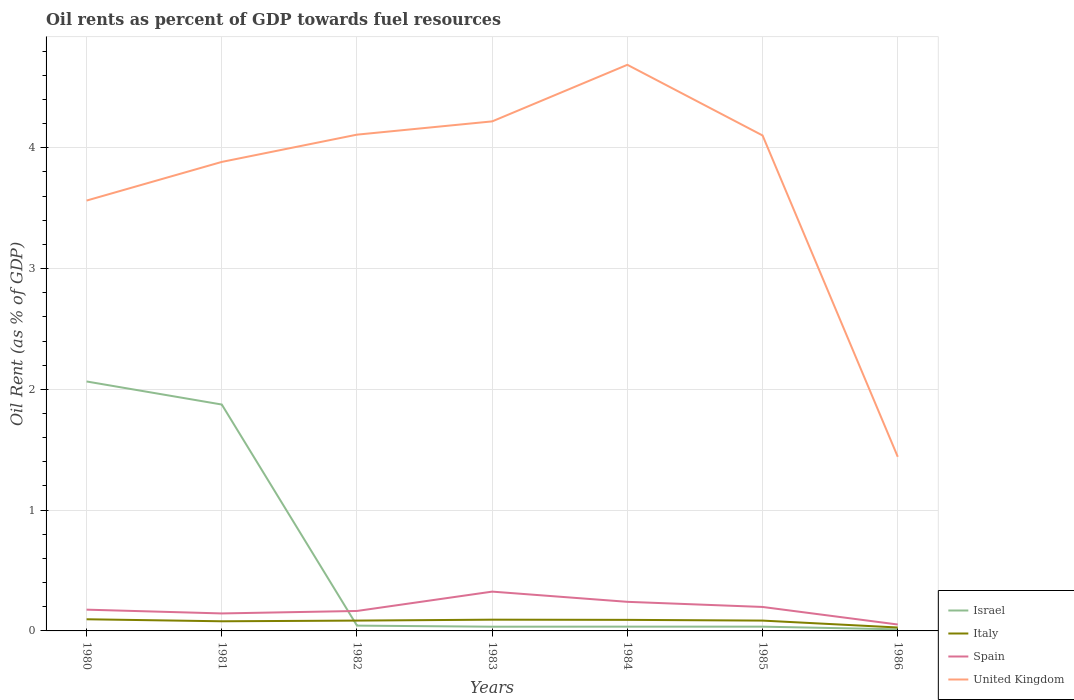How many different coloured lines are there?
Your answer should be very brief. 4. Across all years, what is the maximum oil rent in Israel?
Offer a terse response. 0.01. What is the total oil rent in Israel in the graph?
Give a very brief answer. 0.01. What is the difference between the highest and the second highest oil rent in United Kingdom?
Your response must be concise. 3.25. What is the difference between the highest and the lowest oil rent in United Kingdom?
Keep it short and to the point. 5. Is the oil rent in Spain strictly greater than the oil rent in Israel over the years?
Ensure brevity in your answer.  No. How many years are there in the graph?
Offer a very short reply. 7. What is the difference between two consecutive major ticks on the Y-axis?
Ensure brevity in your answer.  1. Where does the legend appear in the graph?
Offer a very short reply. Bottom right. What is the title of the graph?
Your answer should be very brief. Oil rents as percent of GDP towards fuel resources. Does "Channel Islands" appear as one of the legend labels in the graph?
Provide a short and direct response. No. What is the label or title of the Y-axis?
Your answer should be very brief. Oil Rent (as % of GDP). What is the Oil Rent (as % of GDP) of Israel in 1980?
Keep it short and to the point. 2.07. What is the Oil Rent (as % of GDP) of Italy in 1980?
Your answer should be compact. 0.1. What is the Oil Rent (as % of GDP) in Spain in 1980?
Your answer should be compact. 0.18. What is the Oil Rent (as % of GDP) of United Kingdom in 1980?
Offer a terse response. 3.56. What is the Oil Rent (as % of GDP) in Israel in 1981?
Ensure brevity in your answer.  1.87. What is the Oil Rent (as % of GDP) of Italy in 1981?
Keep it short and to the point. 0.08. What is the Oil Rent (as % of GDP) of Spain in 1981?
Give a very brief answer. 0.14. What is the Oil Rent (as % of GDP) in United Kingdom in 1981?
Give a very brief answer. 3.88. What is the Oil Rent (as % of GDP) of Israel in 1982?
Provide a succinct answer. 0.04. What is the Oil Rent (as % of GDP) of Italy in 1982?
Your response must be concise. 0.09. What is the Oil Rent (as % of GDP) in Spain in 1982?
Ensure brevity in your answer.  0.17. What is the Oil Rent (as % of GDP) of United Kingdom in 1982?
Your answer should be very brief. 4.11. What is the Oil Rent (as % of GDP) in Israel in 1983?
Your answer should be compact. 0.03. What is the Oil Rent (as % of GDP) of Italy in 1983?
Keep it short and to the point. 0.09. What is the Oil Rent (as % of GDP) in Spain in 1983?
Keep it short and to the point. 0.33. What is the Oil Rent (as % of GDP) of United Kingdom in 1983?
Give a very brief answer. 4.22. What is the Oil Rent (as % of GDP) of Israel in 1984?
Ensure brevity in your answer.  0.04. What is the Oil Rent (as % of GDP) in Italy in 1984?
Provide a succinct answer. 0.09. What is the Oil Rent (as % of GDP) in Spain in 1984?
Offer a very short reply. 0.24. What is the Oil Rent (as % of GDP) of United Kingdom in 1984?
Ensure brevity in your answer.  4.69. What is the Oil Rent (as % of GDP) in Israel in 1985?
Make the answer very short. 0.04. What is the Oil Rent (as % of GDP) of Italy in 1985?
Keep it short and to the point. 0.09. What is the Oil Rent (as % of GDP) of Spain in 1985?
Your response must be concise. 0.2. What is the Oil Rent (as % of GDP) of United Kingdom in 1985?
Offer a terse response. 4.1. What is the Oil Rent (as % of GDP) in Israel in 1986?
Give a very brief answer. 0.01. What is the Oil Rent (as % of GDP) of Italy in 1986?
Offer a very short reply. 0.03. What is the Oil Rent (as % of GDP) in Spain in 1986?
Your response must be concise. 0.05. What is the Oil Rent (as % of GDP) of United Kingdom in 1986?
Offer a terse response. 1.44. Across all years, what is the maximum Oil Rent (as % of GDP) of Israel?
Provide a succinct answer. 2.07. Across all years, what is the maximum Oil Rent (as % of GDP) in Italy?
Give a very brief answer. 0.1. Across all years, what is the maximum Oil Rent (as % of GDP) in Spain?
Provide a short and direct response. 0.33. Across all years, what is the maximum Oil Rent (as % of GDP) in United Kingdom?
Give a very brief answer. 4.69. Across all years, what is the minimum Oil Rent (as % of GDP) in Israel?
Your answer should be very brief. 0.01. Across all years, what is the minimum Oil Rent (as % of GDP) in Italy?
Make the answer very short. 0.03. Across all years, what is the minimum Oil Rent (as % of GDP) of Spain?
Keep it short and to the point. 0.05. Across all years, what is the minimum Oil Rent (as % of GDP) of United Kingdom?
Keep it short and to the point. 1.44. What is the total Oil Rent (as % of GDP) in Israel in the graph?
Provide a succinct answer. 4.1. What is the total Oil Rent (as % of GDP) of Italy in the graph?
Offer a terse response. 0.56. What is the total Oil Rent (as % of GDP) of Spain in the graph?
Ensure brevity in your answer.  1.3. What is the total Oil Rent (as % of GDP) in United Kingdom in the graph?
Your response must be concise. 26. What is the difference between the Oil Rent (as % of GDP) of Israel in 1980 and that in 1981?
Your response must be concise. 0.19. What is the difference between the Oil Rent (as % of GDP) in Italy in 1980 and that in 1981?
Offer a very short reply. 0.02. What is the difference between the Oil Rent (as % of GDP) of Spain in 1980 and that in 1981?
Ensure brevity in your answer.  0.03. What is the difference between the Oil Rent (as % of GDP) in United Kingdom in 1980 and that in 1981?
Offer a very short reply. -0.32. What is the difference between the Oil Rent (as % of GDP) of Israel in 1980 and that in 1982?
Keep it short and to the point. 2.02. What is the difference between the Oil Rent (as % of GDP) in Italy in 1980 and that in 1982?
Keep it short and to the point. 0.01. What is the difference between the Oil Rent (as % of GDP) in Spain in 1980 and that in 1982?
Offer a terse response. 0.01. What is the difference between the Oil Rent (as % of GDP) of United Kingdom in 1980 and that in 1982?
Your answer should be very brief. -0.55. What is the difference between the Oil Rent (as % of GDP) of Israel in 1980 and that in 1983?
Your answer should be very brief. 2.03. What is the difference between the Oil Rent (as % of GDP) in Italy in 1980 and that in 1983?
Keep it short and to the point. 0. What is the difference between the Oil Rent (as % of GDP) of Spain in 1980 and that in 1983?
Offer a very short reply. -0.15. What is the difference between the Oil Rent (as % of GDP) in United Kingdom in 1980 and that in 1983?
Make the answer very short. -0.66. What is the difference between the Oil Rent (as % of GDP) of Israel in 1980 and that in 1984?
Your answer should be compact. 2.03. What is the difference between the Oil Rent (as % of GDP) of Italy in 1980 and that in 1984?
Give a very brief answer. 0. What is the difference between the Oil Rent (as % of GDP) of Spain in 1980 and that in 1984?
Offer a terse response. -0.06. What is the difference between the Oil Rent (as % of GDP) in United Kingdom in 1980 and that in 1984?
Offer a very short reply. -1.12. What is the difference between the Oil Rent (as % of GDP) of Israel in 1980 and that in 1985?
Offer a terse response. 2.03. What is the difference between the Oil Rent (as % of GDP) in Italy in 1980 and that in 1985?
Your answer should be very brief. 0.01. What is the difference between the Oil Rent (as % of GDP) in Spain in 1980 and that in 1985?
Give a very brief answer. -0.02. What is the difference between the Oil Rent (as % of GDP) of United Kingdom in 1980 and that in 1985?
Your response must be concise. -0.54. What is the difference between the Oil Rent (as % of GDP) of Israel in 1980 and that in 1986?
Your answer should be compact. 2.05. What is the difference between the Oil Rent (as % of GDP) in Italy in 1980 and that in 1986?
Give a very brief answer. 0.07. What is the difference between the Oil Rent (as % of GDP) of Spain in 1980 and that in 1986?
Give a very brief answer. 0.12. What is the difference between the Oil Rent (as % of GDP) in United Kingdom in 1980 and that in 1986?
Give a very brief answer. 2.12. What is the difference between the Oil Rent (as % of GDP) in Israel in 1981 and that in 1982?
Offer a very short reply. 1.83. What is the difference between the Oil Rent (as % of GDP) of Italy in 1981 and that in 1982?
Offer a very short reply. -0.01. What is the difference between the Oil Rent (as % of GDP) of Spain in 1981 and that in 1982?
Make the answer very short. -0.02. What is the difference between the Oil Rent (as % of GDP) in United Kingdom in 1981 and that in 1982?
Your response must be concise. -0.23. What is the difference between the Oil Rent (as % of GDP) in Israel in 1981 and that in 1983?
Your answer should be compact. 1.84. What is the difference between the Oil Rent (as % of GDP) of Italy in 1981 and that in 1983?
Offer a terse response. -0.01. What is the difference between the Oil Rent (as % of GDP) in Spain in 1981 and that in 1983?
Offer a terse response. -0.18. What is the difference between the Oil Rent (as % of GDP) of United Kingdom in 1981 and that in 1983?
Your answer should be compact. -0.34. What is the difference between the Oil Rent (as % of GDP) in Israel in 1981 and that in 1984?
Your answer should be very brief. 1.84. What is the difference between the Oil Rent (as % of GDP) in Italy in 1981 and that in 1984?
Ensure brevity in your answer.  -0.01. What is the difference between the Oil Rent (as % of GDP) of Spain in 1981 and that in 1984?
Keep it short and to the point. -0.1. What is the difference between the Oil Rent (as % of GDP) of United Kingdom in 1981 and that in 1984?
Your answer should be very brief. -0.8. What is the difference between the Oil Rent (as % of GDP) of Israel in 1981 and that in 1985?
Provide a succinct answer. 1.84. What is the difference between the Oil Rent (as % of GDP) in Italy in 1981 and that in 1985?
Provide a succinct answer. -0.01. What is the difference between the Oil Rent (as % of GDP) of Spain in 1981 and that in 1985?
Ensure brevity in your answer.  -0.05. What is the difference between the Oil Rent (as % of GDP) of United Kingdom in 1981 and that in 1985?
Make the answer very short. -0.22. What is the difference between the Oil Rent (as % of GDP) of Israel in 1981 and that in 1986?
Your answer should be very brief. 1.86. What is the difference between the Oil Rent (as % of GDP) in Italy in 1981 and that in 1986?
Your response must be concise. 0.05. What is the difference between the Oil Rent (as % of GDP) in Spain in 1981 and that in 1986?
Your answer should be compact. 0.09. What is the difference between the Oil Rent (as % of GDP) in United Kingdom in 1981 and that in 1986?
Provide a short and direct response. 2.44. What is the difference between the Oil Rent (as % of GDP) of Israel in 1982 and that in 1983?
Provide a short and direct response. 0.01. What is the difference between the Oil Rent (as % of GDP) of Italy in 1982 and that in 1983?
Your answer should be compact. -0.01. What is the difference between the Oil Rent (as % of GDP) of Spain in 1982 and that in 1983?
Provide a short and direct response. -0.16. What is the difference between the Oil Rent (as % of GDP) of United Kingdom in 1982 and that in 1983?
Make the answer very short. -0.11. What is the difference between the Oil Rent (as % of GDP) of Israel in 1982 and that in 1984?
Give a very brief answer. 0.01. What is the difference between the Oil Rent (as % of GDP) in Italy in 1982 and that in 1984?
Give a very brief answer. -0.01. What is the difference between the Oil Rent (as % of GDP) in Spain in 1982 and that in 1984?
Give a very brief answer. -0.08. What is the difference between the Oil Rent (as % of GDP) of United Kingdom in 1982 and that in 1984?
Your response must be concise. -0.58. What is the difference between the Oil Rent (as % of GDP) of Israel in 1982 and that in 1985?
Offer a very short reply. 0.01. What is the difference between the Oil Rent (as % of GDP) of Italy in 1982 and that in 1985?
Provide a short and direct response. 0. What is the difference between the Oil Rent (as % of GDP) of Spain in 1982 and that in 1985?
Provide a short and direct response. -0.03. What is the difference between the Oil Rent (as % of GDP) of United Kingdom in 1982 and that in 1985?
Your response must be concise. 0.01. What is the difference between the Oil Rent (as % of GDP) in Israel in 1982 and that in 1986?
Offer a very short reply. 0.03. What is the difference between the Oil Rent (as % of GDP) of Italy in 1982 and that in 1986?
Your response must be concise. 0.06. What is the difference between the Oil Rent (as % of GDP) of Spain in 1982 and that in 1986?
Ensure brevity in your answer.  0.11. What is the difference between the Oil Rent (as % of GDP) in United Kingdom in 1982 and that in 1986?
Give a very brief answer. 2.67. What is the difference between the Oil Rent (as % of GDP) in Israel in 1983 and that in 1984?
Your answer should be very brief. -0. What is the difference between the Oil Rent (as % of GDP) of Italy in 1983 and that in 1984?
Provide a short and direct response. 0. What is the difference between the Oil Rent (as % of GDP) in Spain in 1983 and that in 1984?
Make the answer very short. 0.08. What is the difference between the Oil Rent (as % of GDP) in United Kingdom in 1983 and that in 1984?
Offer a very short reply. -0.47. What is the difference between the Oil Rent (as % of GDP) of Israel in 1983 and that in 1985?
Keep it short and to the point. -0. What is the difference between the Oil Rent (as % of GDP) of Italy in 1983 and that in 1985?
Keep it short and to the point. 0.01. What is the difference between the Oil Rent (as % of GDP) of Spain in 1983 and that in 1985?
Keep it short and to the point. 0.13. What is the difference between the Oil Rent (as % of GDP) in United Kingdom in 1983 and that in 1985?
Provide a succinct answer. 0.12. What is the difference between the Oil Rent (as % of GDP) of Israel in 1983 and that in 1986?
Keep it short and to the point. 0.02. What is the difference between the Oil Rent (as % of GDP) in Italy in 1983 and that in 1986?
Give a very brief answer. 0.06. What is the difference between the Oil Rent (as % of GDP) of Spain in 1983 and that in 1986?
Provide a succinct answer. 0.27. What is the difference between the Oil Rent (as % of GDP) in United Kingdom in 1983 and that in 1986?
Provide a succinct answer. 2.78. What is the difference between the Oil Rent (as % of GDP) of Italy in 1984 and that in 1985?
Ensure brevity in your answer.  0.01. What is the difference between the Oil Rent (as % of GDP) of Spain in 1984 and that in 1985?
Make the answer very short. 0.04. What is the difference between the Oil Rent (as % of GDP) in United Kingdom in 1984 and that in 1985?
Provide a short and direct response. 0.58. What is the difference between the Oil Rent (as % of GDP) in Israel in 1984 and that in 1986?
Provide a short and direct response. 0.02. What is the difference between the Oil Rent (as % of GDP) of Italy in 1984 and that in 1986?
Make the answer very short. 0.06. What is the difference between the Oil Rent (as % of GDP) of Spain in 1984 and that in 1986?
Provide a short and direct response. 0.19. What is the difference between the Oil Rent (as % of GDP) of United Kingdom in 1984 and that in 1986?
Offer a very short reply. 3.25. What is the difference between the Oil Rent (as % of GDP) in Israel in 1985 and that in 1986?
Your answer should be compact. 0.02. What is the difference between the Oil Rent (as % of GDP) of Italy in 1985 and that in 1986?
Make the answer very short. 0.06. What is the difference between the Oil Rent (as % of GDP) of Spain in 1985 and that in 1986?
Provide a succinct answer. 0.15. What is the difference between the Oil Rent (as % of GDP) of United Kingdom in 1985 and that in 1986?
Your response must be concise. 2.66. What is the difference between the Oil Rent (as % of GDP) of Israel in 1980 and the Oil Rent (as % of GDP) of Italy in 1981?
Your answer should be compact. 1.99. What is the difference between the Oil Rent (as % of GDP) in Israel in 1980 and the Oil Rent (as % of GDP) in Spain in 1981?
Provide a succinct answer. 1.92. What is the difference between the Oil Rent (as % of GDP) in Israel in 1980 and the Oil Rent (as % of GDP) in United Kingdom in 1981?
Provide a succinct answer. -1.82. What is the difference between the Oil Rent (as % of GDP) of Italy in 1980 and the Oil Rent (as % of GDP) of Spain in 1981?
Your response must be concise. -0.05. What is the difference between the Oil Rent (as % of GDP) of Italy in 1980 and the Oil Rent (as % of GDP) of United Kingdom in 1981?
Your answer should be compact. -3.79. What is the difference between the Oil Rent (as % of GDP) of Spain in 1980 and the Oil Rent (as % of GDP) of United Kingdom in 1981?
Your answer should be very brief. -3.71. What is the difference between the Oil Rent (as % of GDP) of Israel in 1980 and the Oil Rent (as % of GDP) of Italy in 1982?
Ensure brevity in your answer.  1.98. What is the difference between the Oil Rent (as % of GDP) in Israel in 1980 and the Oil Rent (as % of GDP) in Spain in 1982?
Your answer should be compact. 1.9. What is the difference between the Oil Rent (as % of GDP) in Israel in 1980 and the Oil Rent (as % of GDP) in United Kingdom in 1982?
Your answer should be very brief. -2.04. What is the difference between the Oil Rent (as % of GDP) in Italy in 1980 and the Oil Rent (as % of GDP) in Spain in 1982?
Give a very brief answer. -0.07. What is the difference between the Oil Rent (as % of GDP) in Italy in 1980 and the Oil Rent (as % of GDP) in United Kingdom in 1982?
Keep it short and to the point. -4.01. What is the difference between the Oil Rent (as % of GDP) in Spain in 1980 and the Oil Rent (as % of GDP) in United Kingdom in 1982?
Offer a very short reply. -3.93. What is the difference between the Oil Rent (as % of GDP) in Israel in 1980 and the Oil Rent (as % of GDP) in Italy in 1983?
Give a very brief answer. 1.97. What is the difference between the Oil Rent (as % of GDP) in Israel in 1980 and the Oil Rent (as % of GDP) in Spain in 1983?
Your answer should be very brief. 1.74. What is the difference between the Oil Rent (as % of GDP) in Israel in 1980 and the Oil Rent (as % of GDP) in United Kingdom in 1983?
Keep it short and to the point. -2.15. What is the difference between the Oil Rent (as % of GDP) of Italy in 1980 and the Oil Rent (as % of GDP) of Spain in 1983?
Provide a short and direct response. -0.23. What is the difference between the Oil Rent (as % of GDP) in Italy in 1980 and the Oil Rent (as % of GDP) in United Kingdom in 1983?
Provide a short and direct response. -4.12. What is the difference between the Oil Rent (as % of GDP) of Spain in 1980 and the Oil Rent (as % of GDP) of United Kingdom in 1983?
Provide a short and direct response. -4.04. What is the difference between the Oil Rent (as % of GDP) in Israel in 1980 and the Oil Rent (as % of GDP) in Italy in 1984?
Offer a very short reply. 1.97. What is the difference between the Oil Rent (as % of GDP) of Israel in 1980 and the Oil Rent (as % of GDP) of Spain in 1984?
Offer a very short reply. 1.82. What is the difference between the Oil Rent (as % of GDP) of Israel in 1980 and the Oil Rent (as % of GDP) of United Kingdom in 1984?
Keep it short and to the point. -2.62. What is the difference between the Oil Rent (as % of GDP) of Italy in 1980 and the Oil Rent (as % of GDP) of Spain in 1984?
Keep it short and to the point. -0.14. What is the difference between the Oil Rent (as % of GDP) in Italy in 1980 and the Oil Rent (as % of GDP) in United Kingdom in 1984?
Make the answer very short. -4.59. What is the difference between the Oil Rent (as % of GDP) in Spain in 1980 and the Oil Rent (as % of GDP) in United Kingdom in 1984?
Your answer should be very brief. -4.51. What is the difference between the Oil Rent (as % of GDP) in Israel in 1980 and the Oil Rent (as % of GDP) in Italy in 1985?
Your response must be concise. 1.98. What is the difference between the Oil Rent (as % of GDP) of Israel in 1980 and the Oil Rent (as % of GDP) of Spain in 1985?
Your answer should be compact. 1.87. What is the difference between the Oil Rent (as % of GDP) in Israel in 1980 and the Oil Rent (as % of GDP) in United Kingdom in 1985?
Keep it short and to the point. -2.04. What is the difference between the Oil Rent (as % of GDP) of Italy in 1980 and the Oil Rent (as % of GDP) of Spain in 1985?
Ensure brevity in your answer.  -0.1. What is the difference between the Oil Rent (as % of GDP) in Italy in 1980 and the Oil Rent (as % of GDP) in United Kingdom in 1985?
Your answer should be compact. -4.01. What is the difference between the Oil Rent (as % of GDP) in Spain in 1980 and the Oil Rent (as % of GDP) in United Kingdom in 1985?
Provide a short and direct response. -3.93. What is the difference between the Oil Rent (as % of GDP) of Israel in 1980 and the Oil Rent (as % of GDP) of Italy in 1986?
Give a very brief answer. 2.04. What is the difference between the Oil Rent (as % of GDP) in Israel in 1980 and the Oil Rent (as % of GDP) in Spain in 1986?
Give a very brief answer. 2.01. What is the difference between the Oil Rent (as % of GDP) in Israel in 1980 and the Oil Rent (as % of GDP) in United Kingdom in 1986?
Keep it short and to the point. 0.62. What is the difference between the Oil Rent (as % of GDP) of Italy in 1980 and the Oil Rent (as % of GDP) of Spain in 1986?
Provide a succinct answer. 0.04. What is the difference between the Oil Rent (as % of GDP) in Italy in 1980 and the Oil Rent (as % of GDP) in United Kingdom in 1986?
Your answer should be compact. -1.34. What is the difference between the Oil Rent (as % of GDP) in Spain in 1980 and the Oil Rent (as % of GDP) in United Kingdom in 1986?
Your response must be concise. -1.27. What is the difference between the Oil Rent (as % of GDP) of Israel in 1981 and the Oil Rent (as % of GDP) of Italy in 1982?
Make the answer very short. 1.79. What is the difference between the Oil Rent (as % of GDP) in Israel in 1981 and the Oil Rent (as % of GDP) in Spain in 1982?
Keep it short and to the point. 1.71. What is the difference between the Oil Rent (as % of GDP) of Israel in 1981 and the Oil Rent (as % of GDP) of United Kingdom in 1982?
Your answer should be compact. -2.23. What is the difference between the Oil Rent (as % of GDP) in Italy in 1981 and the Oil Rent (as % of GDP) in Spain in 1982?
Your answer should be very brief. -0.09. What is the difference between the Oil Rent (as % of GDP) in Italy in 1981 and the Oil Rent (as % of GDP) in United Kingdom in 1982?
Give a very brief answer. -4.03. What is the difference between the Oil Rent (as % of GDP) of Spain in 1981 and the Oil Rent (as % of GDP) of United Kingdom in 1982?
Provide a succinct answer. -3.96. What is the difference between the Oil Rent (as % of GDP) of Israel in 1981 and the Oil Rent (as % of GDP) of Italy in 1983?
Your answer should be very brief. 1.78. What is the difference between the Oil Rent (as % of GDP) of Israel in 1981 and the Oil Rent (as % of GDP) of Spain in 1983?
Make the answer very short. 1.55. What is the difference between the Oil Rent (as % of GDP) in Israel in 1981 and the Oil Rent (as % of GDP) in United Kingdom in 1983?
Offer a terse response. -2.34. What is the difference between the Oil Rent (as % of GDP) of Italy in 1981 and the Oil Rent (as % of GDP) of Spain in 1983?
Make the answer very short. -0.25. What is the difference between the Oil Rent (as % of GDP) of Italy in 1981 and the Oil Rent (as % of GDP) of United Kingdom in 1983?
Make the answer very short. -4.14. What is the difference between the Oil Rent (as % of GDP) in Spain in 1981 and the Oil Rent (as % of GDP) in United Kingdom in 1983?
Your response must be concise. -4.07. What is the difference between the Oil Rent (as % of GDP) in Israel in 1981 and the Oil Rent (as % of GDP) in Italy in 1984?
Give a very brief answer. 1.78. What is the difference between the Oil Rent (as % of GDP) in Israel in 1981 and the Oil Rent (as % of GDP) in Spain in 1984?
Offer a terse response. 1.63. What is the difference between the Oil Rent (as % of GDP) of Israel in 1981 and the Oil Rent (as % of GDP) of United Kingdom in 1984?
Provide a short and direct response. -2.81. What is the difference between the Oil Rent (as % of GDP) of Italy in 1981 and the Oil Rent (as % of GDP) of Spain in 1984?
Your answer should be very brief. -0.16. What is the difference between the Oil Rent (as % of GDP) in Italy in 1981 and the Oil Rent (as % of GDP) in United Kingdom in 1984?
Your answer should be very brief. -4.61. What is the difference between the Oil Rent (as % of GDP) in Spain in 1981 and the Oil Rent (as % of GDP) in United Kingdom in 1984?
Offer a terse response. -4.54. What is the difference between the Oil Rent (as % of GDP) in Israel in 1981 and the Oil Rent (as % of GDP) in Italy in 1985?
Keep it short and to the point. 1.79. What is the difference between the Oil Rent (as % of GDP) in Israel in 1981 and the Oil Rent (as % of GDP) in Spain in 1985?
Provide a short and direct response. 1.68. What is the difference between the Oil Rent (as % of GDP) of Israel in 1981 and the Oil Rent (as % of GDP) of United Kingdom in 1985?
Give a very brief answer. -2.23. What is the difference between the Oil Rent (as % of GDP) of Italy in 1981 and the Oil Rent (as % of GDP) of Spain in 1985?
Offer a terse response. -0.12. What is the difference between the Oil Rent (as % of GDP) in Italy in 1981 and the Oil Rent (as % of GDP) in United Kingdom in 1985?
Keep it short and to the point. -4.02. What is the difference between the Oil Rent (as % of GDP) in Spain in 1981 and the Oil Rent (as % of GDP) in United Kingdom in 1985?
Make the answer very short. -3.96. What is the difference between the Oil Rent (as % of GDP) of Israel in 1981 and the Oil Rent (as % of GDP) of Italy in 1986?
Keep it short and to the point. 1.85. What is the difference between the Oil Rent (as % of GDP) in Israel in 1981 and the Oil Rent (as % of GDP) in Spain in 1986?
Provide a short and direct response. 1.82. What is the difference between the Oil Rent (as % of GDP) in Israel in 1981 and the Oil Rent (as % of GDP) in United Kingdom in 1986?
Your response must be concise. 0.43. What is the difference between the Oil Rent (as % of GDP) in Italy in 1981 and the Oil Rent (as % of GDP) in Spain in 1986?
Offer a very short reply. 0.03. What is the difference between the Oil Rent (as % of GDP) in Italy in 1981 and the Oil Rent (as % of GDP) in United Kingdom in 1986?
Your answer should be very brief. -1.36. What is the difference between the Oil Rent (as % of GDP) of Spain in 1981 and the Oil Rent (as % of GDP) of United Kingdom in 1986?
Your answer should be compact. -1.3. What is the difference between the Oil Rent (as % of GDP) in Israel in 1982 and the Oil Rent (as % of GDP) in Italy in 1983?
Give a very brief answer. -0.05. What is the difference between the Oil Rent (as % of GDP) in Israel in 1982 and the Oil Rent (as % of GDP) in Spain in 1983?
Provide a short and direct response. -0.28. What is the difference between the Oil Rent (as % of GDP) in Israel in 1982 and the Oil Rent (as % of GDP) in United Kingdom in 1983?
Give a very brief answer. -4.17. What is the difference between the Oil Rent (as % of GDP) in Italy in 1982 and the Oil Rent (as % of GDP) in Spain in 1983?
Give a very brief answer. -0.24. What is the difference between the Oil Rent (as % of GDP) of Italy in 1982 and the Oil Rent (as % of GDP) of United Kingdom in 1983?
Ensure brevity in your answer.  -4.13. What is the difference between the Oil Rent (as % of GDP) of Spain in 1982 and the Oil Rent (as % of GDP) of United Kingdom in 1983?
Make the answer very short. -4.05. What is the difference between the Oil Rent (as % of GDP) of Israel in 1982 and the Oil Rent (as % of GDP) of Italy in 1984?
Make the answer very short. -0.05. What is the difference between the Oil Rent (as % of GDP) in Israel in 1982 and the Oil Rent (as % of GDP) in Spain in 1984?
Keep it short and to the point. -0.2. What is the difference between the Oil Rent (as % of GDP) of Israel in 1982 and the Oil Rent (as % of GDP) of United Kingdom in 1984?
Provide a short and direct response. -4.64. What is the difference between the Oil Rent (as % of GDP) in Italy in 1982 and the Oil Rent (as % of GDP) in Spain in 1984?
Provide a succinct answer. -0.16. What is the difference between the Oil Rent (as % of GDP) of Italy in 1982 and the Oil Rent (as % of GDP) of United Kingdom in 1984?
Provide a succinct answer. -4.6. What is the difference between the Oil Rent (as % of GDP) in Spain in 1982 and the Oil Rent (as % of GDP) in United Kingdom in 1984?
Give a very brief answer. -4.52. What is the difference between the Oil Rent (as % of GDP) in Israel in 1982 and the Oil Rent (as % of GDP) in Italy in 1985?
Offer a terse response. -0.04. What is the difference between the Oil Rent (as % of GDP) of Israel in 1982 and the Oil Rent (as % of GDP) of Spain in 1985?
Keep it short and to the point. -0.15. What is the difference between the Oil Rent (as % of GDP) in Israel in 1982 and the Oil Rent (as % of GDP) in United Kingdom in 1985?
Your answer should be very brief. -4.06. What is the difference between the Oil Rent (as % of GDP) of Italy in 1982 and the Oil Rent (as % of GDP) of Spain in 1985?
Your answer should be compact. -0.11. What is the difference between the Oil Rent (as % of GDP) of Italy in 1982 and the Oil Rent (as % of GDP) of United Kingdom in 1985?
Ensure brevity in your answer.  -4.02. What is the difference between the Oil Rent (as % of GDP) in Spain in 1982 and the Oil Rent (as % of GDP) in United Kingdom in 1985?
Keep it short and to the point. -3.94. What is the difference between the Oil Rent (as % of GDP) in Israel in 1982 and the Oil Rent (as % of GDP) in Italy in 1986?
Give a very brief answer. 0.02. What is the difference between the Oil Rent (as % of GDP) in Israel in 1982 and the Oil Rent (as % of GDP) in Spain in 1986?
Provide a succinct answer. -0.01. What is the difference between the Oil Rent (as % of GDP) of Israel in 1982 and the Oil Rent (as % of GDP) of United Kingdom in 1986?
Keep it short and to the point. -1.4. What is the difference between the Oil Rent (as % of GDP) of Italy in 1982 and the Oil Rent (as % of GDP) of Spain in 1986?
Give a very brief answer. 0.03. What is the difference between the Oil Rent (as % of GDP) of Italy in 1982 and the Oil Rent (as % of GDP) of United Kingdom in 1986?
Provide a short and direct response. -1.36. What is the difference between the Oil Rent (as % of GDP) in Spain in 1982 and the Oil Rent (as % of GDP) in United Kingdom in 1986?
Offer a very short reply. -1.28. What is the difference between the Oil Rent (as % of GDP) of Israel in 1983 and the Oil Rent (as % of GDP) of Italy in 1984?
Ensure brevity in your answer.  -0.06. What is the difference between the Oil Rent (as % of GDP) in Israel in 1983 and the Oil Rent (as % of GDP) in Spain in 1984?
Ensure brevity in your answer.  -0.21. What is the difference between the Oil Rent (as % of GDP) in Israel in 1983 and the Oil Rent (as % of GDP) in United Kingdom in 1984?
Offer a terse response. -4.65. What is the difference between the Oil Rent (as % of GDP) in Italy in 1983 and the Oil Rent (as % of GDP) in Spain in 1984?
Give a very brief answer. -0.15. What is the difference between the Oil Rent (as % of GDP) of Italy in 1983 and the Oil Rent (as % of GDP) of United Kingdom in 1984?
Your answer should be compact. -4.59. What is the difference between the Oil Rent (as % of GDP) of Spain in 1983 and the Oil Rent (as % of GDP) of United Kingdom in 1984?
Provide a short and direct response. -4.36. What is the difference between the Oil Rent (as % of GDP) of Israel in 1983 and the Oil Rent (as % of GDP) of Italy in 1985?
Provide a succinct answer. -0.05. What is the difference between the Oil Rent (as % of GDP) in Israel in 1983 and the Oil Rent (as % of GDP) in Spain in 1985?
Make the answer very short. -0.16. What is the difference between the Oil Rent (as % of GDP) of Israel in 1983 and the Oil Rent (as % of GDP) of United Kingdom in 1985?
Ensure brevity in your answer.  -4.07. What is the difference between the Oil Rent (as % of GDP) of Italy in 1983 and the Oil Rent (as % of GDP) of Spain in 1985?
Your answer should be compact. -0.11. What is the difference between the Oil Rent (as % of GDP) in Italy in 1983 and the Oil Rent (as % of GDP) in United Kingdom in 1985?
Provide a short and direct response. -4.01. What is the difference between the Oil Rent (as % of GDP) in Spain in 1983 and the Oil Rent (as % of GDP) in United Kingdom in 1985?
Give a very brief answer. -3.78. What is the difference between the Oil Rent (as % of GDP) of Israel in 1983 and the Oil Rent (as % of GDP) of Italy in 1986?
Make the answer very short. 0.01. What is the difference between the Oil Rent (as % of GDP) in Israel in 1983 and the Oil Rent (as % of GDP) in Spain in 1986?
Your response must be concise. -0.02. What is the difference between the Oil Rent (as % of GDP) in Israel in 1983 and the Oil Rent (as % of GDP) in United Kingdom in 1986?
Your answer should be compact. -1.41. What is the difference between the Oil Rent (as % of GDP) in Italy in 1983 and the Oil Rent (as % of GDP) in Spain in 1986?
Your answer should be very brief. 0.04. What is the difference between the Oil Rent (as % of GDP) of Italy in 1983 and the Oil Rent (as % of GDP) of United Kingdom in 1986?
Ensure brevity in your answer.  -1.35. What is the difference between the Oil Rent (as % of GDP) in Spain in 1983 and the Oil Rent (as % of GDP) in United Kingdom in 1986?
Make the answer very short. -1.12. What is the difference between the Oil Rent (as % of GDP) of Israel in 1984 and the Oil Rent (as % of GDP) of Italy in 1985?
Give a very brief answer. -0.05. What is the difference between the Oil Rent (as % of GDP) of Israel in 1984 and the Oil Rent (as % of GDP) of Spain in 1985?
Your response must be concise. -0.16. What is the difference between the Oil Rent (as % of GDP) of Israel in 1984 and the Oil Rent (as % of GDP) of United Kingdom in 1985?
Provide a short and direct response. -4.07. What is the difference between the Oil Rent (as % of GDP) of Italy in 1984 and the Oil Rent (as % of GDP) of Spain in 1985?
Your answer should be compact. -0.11. What is the difference between the Oil Rent (as % of GDP) of Italy in 1984 and the Oil Rent (as % of GDP) of United Kingdom in 1985?
Your response must be concise. -4.01. What is the difference between the Oil Rent (as % of GDP) in Spain in 1984 and the Oil Rent (as % of GDP) in United Kingdom in 1985?
Offer a very short reply. -3.86. What is the difference between the Oil Rent (as % of GDP) of Israel in 1984 and the Oil Rent (as % of GDP) of Italy in 1986?
Your answer should be very brief. 0.01. What is the difference between the Oil Rent (as % of GDP) of Israel in 1984 and the Oil Rent (as % of GDP) of Spain in 1986?
Provide a short and direct response. -0.02. What is the difference between the Oil Rent (as % of GDP) of Israel in 1984 and the Oil Rent (as % of GDP) of United Kingdom in 1986?
Your answer should be compact. -1.41. What is the difference between the Oil Rent (as % of GDP) in Italy in 1984 and the Oil Rent (as % of GDP) in Spain in 1986?
Your answer should be very brief. 0.04. What is the difference between the Oil Rent (as % of GDP) of Italy in 1984 and the Oil Rent (as % of GDP) of United Kingdom in 1986?
Ensure brevity in your answer.  -1.35. What is the difference between the Oil Rent (as % of GDP) in Spain in 1984 and the Oil Rent (as % of GDP) in United Kingdom in 1986?
Ensure brevity in your answer.  -1.2. What is the difference between the Oil Rent (as % of GDP) in Israel in 1985 and the Oil Rent (as % of GDP) in Italy in 1986?
Offer a very short reply. 0.01. What is the difference between the Oil Rent (as % of GDP) in Israel in 1985 and the Oil Rent (as % of GDP) in Spain in 1986?
Ensure brevity in your answer.  -0.02. What is the difference between the Oil Rent (as % of GDP) in Israel in 1985 and the Oil Rent (as % of GDP) in United Kingdom in 1986?
Offer a very short reply. -1.41. What is the difference between the Oil Rent (as % of GDP) in Italy in 1985 and the Oil Rent (as % of GDP) in Spain in 1986?
Ensure brevity in your answer.  0.03. What is the difference between the Oil Rent (as % of GDP) in Italy in 1985 and the Oil Rent (as % of GDP) in United Kingdom in 1986?
Provide a short and direct response. -1.36. What is the difference between the Oil Rent (as % of GDP) of Spain in 1985 and the Oil Rent (as % of GDP) of United Kingdom in 1986?
Offer a very short reply. -1.24. What is the average Oil Rent (as % of GDP) of Israel per year?
Keep it short and to the point. 0.59. What is the average Oil Rent (as % of GDP) in Spain per year?
Offer a very short reply. 0.19. What is the average Oil Rent (as % of GDP) in United Kingdom per year?
Ensure brevity in your answer.  3.71. In the year 1980, what is the difference between the Oil Rent (as % of GDP) of Israel and Oil Rent (as % of GDP) of Italy?
Your answer should be very brief. 1.97. In the year 1980, what is the difference between the Oil Rent (as % of GDP) in Israel and Oil Rent (as % of GDP) in Spain?
Your answer should be very brief. 1.89. In the year 1980, what is the difference between the Oil Rent (as % of GDP) of Israel and Oil Rent (as % of GDP) of United Kingdom?
Provide a short and direct response. -1.5. In the year 1980, what is the difference between the Oil Rent (as % of GDP) of Italy and Oil Rent (as % of GDP) of Spain?
Your answer should be very brief. -0.08. In the year 1980, what is the difference between the Oil Rent (as % of GDP) of Italy and Oil Rent (as % of GDP) of United Kingdom?
Provide a short and direct response. -3.47. In the year 1980, what is the difference between the Oil Rent (as % of GDP) in Spain and Oil Rent (as % of GDP) in United Kingdom?
Give a very brief answer. -3.39. In the year 1981, what is the difference between the Oil Rent (as % of GDP) in Israel and Oil Rent (as % of GDP) in Italy?
Offer a terse response. 1.79. In the year 1981, what is the difference between the Oil Rent (as % of GDP) in Israel and Oil Rent (as % of GDP) in Spain?
Ensure brevity in your answer.  1.73. In the year 1981, what is the difference between the Oil Rent (as % of GDP) of Israel and Oil Rent (as % of GDP) of United Kingdom?
Give a very brief answer. -2.01. In the year 1981, what is the difference between the Oil Rent (as % of GDP) in Italy and Oil Rent (as % of GDP) in Spain?
Provide a short and direct response. -0.06. In the year 1981, what is the difference between the Oil Rent (as % of GDP) in Italy and Oil Rent (as % of GDP) in United Kingdom?
Your answer should be very brief. -3.8. In the year 1981, what is the difference between the Oil Rent (as % of GDP) of Spain and Oil Rent (as % of GDP) of United Kingdom?
Keep it short and to the point. -3.74. In the year 1982, what is the difference between the Oil Rent (as % of GDP) in Israel and Oil Rent (as % of GDP) in Italy?
Your answer should be very brief. -0.04. In the year 1982, what is the difference between the Oil Rent (as % of GDP) in Israel and Oil Rent (as % of GDP) in Spain?
Make the answer very short. -0.12. In the year 1982, what is the difference between the Oil Rent (as % of GDP) of Israel and Oil Rent (as % of GDP) of United Kingdom?
Offer a terse response. -4.06. In the year 1982, what is the difference between the Oil Rent (as % of GDP) of Italy and Oil Rent (as % of GDP) of Spain?
Provide a succinct answer. -0.08. In the year 1982, what is the difference between the Oil Rent (as % of GDP) in Italy and Oil Rent (as % of GDP) in United Kingdom?
Your answer should be compact. -4.02. In the year 1982, what is the difference between the Oil Rent (as % of GDP) of Spain and Oil Rent (as % of GDP) of United Kingdom?
Keep it short and to the point. -3.94. In the year 1983, what is the difference between the Oil Rent (as % of GDP) in Israel and Oil Rent (as % of GDP) in Italy?
Keep it short and to the point. -0.06. In the year 1983, what is the difference between the Oil Rent (as % of GDP) in Israel and Oil Rent (as % of GDP) in Spain?
Keep it short and to the point. -0.29. In the year 1983, what is the difference between the Oil Rent (as % of GDP) in Israel and Oil Rent (as % of GDP) in United Kingdom?
Your response must be concise. -4.18. In the year 1983, what is the difference between the Oil Rent (as % of GDP) in Italy and Oil Rent (as % of GDP) in Spain?
Your answer should be compact. -0.23. In the year 1983, what is the difference between the Oil Rent (as % of GDP) of Italy and Oil Rent (as % of GDP) of United Kingdom?
Give a very brief answer. -4.13. In the year 1983, what is the difference between the Oil Rent (as % of GDP) of Spain and Oil Rent (as % of GDP) of United Kingdom?
Keep it short and to the point. -3.89. In the year 1984, what is the difference between the Oil Rent (as % of GDP) of Israel and Oil Rent (as % of GDP) of Italy?
Your answer should be compact. -0.06. In the year 1984, what is the difference between the Oil Rent (as % of GDP) in Israel and Oil Rent (as % of GDP) in Spain?
Make the answer very short. -0.21. In the year 1984, what is the difference between the Oil Rent (as % of GDP) of Israel and Oil Rent (as % of GDP) of United Kingdom?
Make the answer very short. -4.65. In the year 1984, what is the difference between the Oil Rent (as % of GDP) in Italy and Oil Rent (as % of GDP) in Spain?
Your answer should be compact. -0.15. In the year 1984, what is the difference between the Oil Rent (as % of GDP) of Italy and Oil Rent (as % of GDP) of United Kingdom?
Make the answer very short. -4.6. In the year 1984, what is the difference between the Oil Rent (as % of GDP) in Spain and Oil Rent (as % of GDP) in United Kingdom?
Make the answer very short. -4.45. In the year 1985, what is the difference between the Oil Rent (as % of GDP) of Israel and Oil Rent (as % of GDP) of Italy?
Offer a very short reply. -0.05. In the year 1985, what is the difference between the Oil Rent (as % of GDP) in Israel and Oil Rent (as % of GDP) in Spain?
Provide a short and direct response. -0.16. In the year 1985, what is the difference between the Oil Rent (as % of GDP) of Israel and Oil Rent (as % of GDP) of United Kingdom?
Give a very brief answer. -4.07. In the year 1985, what is the difference between the Oil Rent (as % of GDP) in Italy and Oil Rent (as % of GDP) in Spain?
Your answer should be very brief. -0.11. In the year 1985, what is the difference between the Oil Rent (as % of GDP) of Italy and Oil Rent (as % of GDP) of United Kingdom?
Ensure brevity in your answer.  -4.02. In the year 1985, what is the difference between the Oil Rent (as % of GDP) of Spain and Oil Rent (as % of GDP) of United Kingdom?
Provide a short and direct response. -3.9. In the year 1986, what is the difference between the Oil Rent (as % of GDP) of Israel and Oil Rent (as % of GDP) of Italy?
Provide a succinct answer. -0.02. In the year 1986, what is the difference between the Oil Rent (as % of GDP) of Israel and Oil Rent (as % of GDP) of Spain?
Give a very brief answer. -0.04. In the year 1986, what is the difference between the Oil Rent (as % of GDP) of Israel and Oil Rent (as % of GDP) of United Kingdom?
Your response must be concise. -1.43. In the year 1986, what is the difference between the Oil Rent (as % of GDP) in Italy and Oil Rent (as % of GDP) in Spain?
Ensure brevity in your answer.  -0.02. In the year 1986, what is the difference between the Oil Rent (as % of GDP) of Italy and Oil Rent (as % of GDP) of United Kingdom?
Make the answer very short. -1.41. In the year 1986, what is the difference between the Oil Rent (as % of GDP) of Spain and Oil Rent (as % of GDP) of United Kingdom?
Your response must be concise. -1.39. What is the ratio of the Oil Rent (as % of GDP) in Israel in 1980 to that in 1981?
Provide a short and direct response. 1.1. What is the ratio of the Oil Rent (as % of GDP) of Italy in 1980 to that in 1981?
Your answer should be compact. 1.21. What is the ratio of the Oil Rent (as % of GDP) of Spain in 1980 to that in 1981?
Provide a succinct answer. 1.22. What is the ratio of the Oil Rent (as % of GDP) in United Kingdom in 1980 to that in 1981?
Offer a very short reply. 0.92. What is the ratio of the Oil Rent (as % of GDP) of Israel in 1980 to that in 1982?
Your response must be concise. 47.09. What is the ratio of the Oil Rent (as % of GDP) of Italy in 1980 to that in 1982?
Your answer should be very brief. 1.13. What is the ratio of the Oil Rent (as % of GDP) in Spain in 1980 to that in 1982?
Offer a very short reply. 1.07. What is the ratio of the Oil Rent (as % of GDP) of United Kingdom in 1980 to that in 1982?
Offer a very short reply. 0.87. What is the ratio of the Oil Rent (as % of GDP) in Israel in 1980 to that in 1983?
Your answer should be compact. 59.1. What is the ratio of the Oil Rent (as % of GDP) of Italy in 1980 to that in 1983?
Provide a short and direct response. 1.04. What is the ratio of the Oil Rent (as % of GDP) of Spain in 1980 to that in 1983?
Ensure brevity in your answer.  0.54. What is the ratio of the Oil Rent (as % of GDP) of United Kingdom in 1980 to that in 1983?
Give a very brief answer. 0.84. What is the ratio of the Oil Rent (as % of GDP) in Israel in 1980 to that in 1984?
Your answer should be very brief. 58.34. What is the ratio of the Oil Rent (as % of GDP) in Italy in 1980 to that in 1984?
Offer a terse response. 1.05. What is the ratio of the Oil Rent (as % of GDP) of Spain in 1980 to that in 1984?
Offer a very short reply. 0.73. What is the ratio of the Oil Rent (as % of GDP) in United Kingdom in 1980 to that in 1984?
Your response must be concise. 0.76. What is the ratio of the Oil Rent (as % of GDP) in Israel in 1980 to that in 1985?
Keep it short and to the point. 58.48. What is the ratio of the Oil Rent (as % of GDP) of Italy in 1980 to that in 1985?
Offer a terse response. 1.13. What is the ratio of the Oil Rent (as % of GDP) in Spain in 1980 to that in 1985?
Offer a terse response. 0.89. What is the ratio of the Oil Rent (as % of GDP) in United Kingdom in 1980 to that in 1985?
Make the answer very short. 0.87. What is the ratio of the Oil Rent (as % of GDP) of Israel in 1980 to that in 1986?
Offer a very short reply. 156.42. What is the ratio of the Oil Rent (as % of GDP) of Italy in 1980 to that in 1986?
Your response must be concise. 3.41. What is the ratio of the Oil Rent (as % of GDP) of Spain in 1980 to that in 1986?
Offer a terse response. 3.32. What is the ratio of the Oil Rent (as % of GDP) of United Kingdom in 1980 to that in 1986?
Make the answer very short. 2.47. What is the ratio of the Oil Rent (as % of GDP) of Israel in 1981 to that in 1982?
Your response must be concise. 42.74. What is the ratio of the Oil Rent (as % of GDP) of Italy in 1981 to that in 1982?
Make the answer very short. 0.93. What is the ratio of the Oil Rent (as % of GDP) in Spain in 1981 to that in 1982?
Provide a short and direct response. 0.88. What is the ratio of the Oil Rent (as % of GDP) of United Kingdom in 1981 to that in 1982?
Offer a terse response. 0.95. What is the ratio of the Oil Rent (as % of GDP) in Israel in 1981 to that in 1983?
Make the answer very short. 53.64. What is the ratio of the Oil Rent (as % of GDP) of Spain in 1981 to that in 1983?
Your answer should be compact. 0.44. What is the ratio of the Oil Rent (as % of GDP) of United Kingdom in 1981 to that in 1983?
Your answer should be very brief. 0.92. What is the ratio of the Oil Rent (as % of GDP) of Israel in 1981 to that in 1984?
Your answer should be very brief. 52.94. What is the ratio of the Oil Rent (as % of GDP) in Italy in 1981 to that in 1984?
Keep it short and to the point. 0.87. What is the ratio of the Oil Rent (as % of GDP) of Spain in 1981 to that in 1984?
Ensure brevity in your answer.  0.6. What is the ratio of the Oil Rent (as % of GDP) of United Kingdom in 1981 to that in 1984?
Make the answer very short. 0.83. What is the ratio of the Oil Rent (as % of GDP) in Israel in 1981 to that in 1985?
Provide a short and direct response. 53.07. What is the ratio of the Oil Rent (as % of GDP) of Italy in 1981 to that in 1985?
Give a very brief answer. 0.93. What is the ratio of the Oil Rent (as % of GDP) in Spain in 1981 to that in 1985?
Keep it short and to the point. 0.73. What is the ratio of the Oil Rent (as % of GDP) of United Kingdom in 1981 to that in 1985?
Offer a terse response. 0.95. What is the ratio of the Oil Rent (as % of GDP) in Israel in 1981 to that in 1986?
Ensure brevity in your answer.  141.97. What is the ratio of the Oil Rent (as % of GDP) of Italy in 1981 to that in 1986?
Offer a terse response. 2.82. What is the ratio of the Oil Rent (as % of GDP) in Spain in 1981 to that in 1986?
Offer a terse response. 2.73. What is the ratio of the Oil Rent (as % of GDP) of United Kingdom in 1981 to that in 1986?
Provide a short and direct response. 2.69. What is the ratio of the Oil Rent (as % of GDP) of Israel in 1982 to that in 1983?
Provide a short and direct response. 1.26. What is the ratio of the Oil Rent (as % of GDP) of Italy in 1982 to that in 1983?
Your response must be concise. 0.92. What is the ratio of the Oil Rent (as % of GDP) in Spain in 1982 to that in 1983?
Make the answer very short. 0.51. What is the ratio of the Oil Rent (as % of GDP) of United Kingdom in 1982 to that in 1983?
Ensure brevity in your answer.  0.97. What is the ratio of the Oil Rent (as % of GDP) of Israel in 1982 to that in 1984?
Make the answer very short. 1.24. What is the ratio of the Oil Rent (as % of GDP) in Italy in 1982 to that in 1984?
Ensure brevity in your answer.  0.93. What is the ratio of the Oil Rent (as % of GDP) in Spain in 1982 to that in 1984?
Give a very brief answer. 0.69. What is the ratio of the Oil Rent (as % of GDP) of United Kingdom in 1982 to that in 1984?
Give a very brief answer. 0.88. What is the ratio of the Oil Rent (as % of GDP) of Israel in 1982 to that in 1985?
Give a very brief answer. 1.24. What is the ratio of the Oil Rent (as % of GDP) in Spain in 1982 to that in 1985?
Offer a terse response. 0.83. What is the ratio of the Oil Rent (as % of GDP) of United Kingdom in 1982 to that in 1985?
Your answer should be very brief. 1. What is the ratio of the Oil Rent (as % of GDP) of Israel in 1982 to that in 1986?
Provide a succinct answer. 3.32. What is the ratio of the Oil Rent (as % of GDP) of Italy in 1982 to that in 1986?
Offer a terse response. 3.02. What is the ratio of the Oil Rent (as % of GDP) in Spain in 1982 to that in 1986?
Provide a short and direct response. 3.11. What is the ratio of the Oil Rent (as % of GDP) in United Kingdom in 1982 to that in 1986?
Your answer should be very brief. 2.85. What is the ratio of the Oil Rent (as % of GDP) in Italy in 1983 to that in 1984?
Your answer should be very brief. 1.02. What is the ratio of the Oil Rent (as % of GDP) of Spain in 1983 to that in 1984?
Give a very brief answer. 1.35. What is the ratio of the Oil Rent (as % of GDP) of United Kingdom in 1983 to that in 1984?
Offer a very short reply. 0.9. What is the ratio of the Oil Rent (as % of GDP) in Italy in 1983 to that in 1985?
Provide a succinct answer. 1.09. What is the ratio of the Oil Rent (as % of GDP) in Spain in 1983 to that in 1985?
Make the answer very short. 1.64. What is the ratio of the Oil Rent (as % of GDP) of United Kingdom in 1983 to that in 1985?
Your response must be concise. 1.03. What is the ratio of the Oil Rent (as % of GDP) of Israel in 1983 to that in 1986?
Provide a short and direct response. 2.65. What is the ratio of the Oil Rent (as % of GDP) in Italy in 1983 to that in 1986?
Offer a terse response. 3.29. What is the ratio of the Oil Rent (as % of GDP) in Spain in 1983 to that in 1986?
Your response must be concise. 6.13. What is the ratio of the Oil Rent (as % of GDP) of United Kingdom in 1983 to that in 1986?
Offer a very short reply. 2.93. What is the ratio of the Oil Rent (as % of GDP) in Italy in 1984 to that in 1985?
Make the answer very short. 1.07. What is the ratio of the Oil Rent (as % of GDP) of Spain in 1984 to that in 1985?
Offer a very short reply. 1.21. What is the ratio of the Oil Rent (as % of GDP) of United Kingdom in 1984 to that in 1985?
Offer a very short reply. 1.14. What is the ratio of the Oil Rent (as % of GDP) of Israel in 1984 to that in 1986?
Keep it short and to the point. 2.68. What is the ratio of the Oil Rent (as % of GDP) in Italy in 1984 to that in 1986?
Provide a short and direct response. 3.23. What is the ratio of the Oil Rent (as % of GDP) in Spain in 1984 to that in 1986?
Your response must be concise. 4.54. What is the ratio of the Oil Rent (as % of GDP) in United Kingdom in 1984 to that in 1986?
Give a very brief answer. 3.25. What is the ratio of the Oil Rent (as % of GDP) of Israel in 1985 to that in 1986?
Give a very brief answer. 2.67. What is the ratio of the Oil Rent (as % of GDP) of Italy in 1985 to that in 1986?
Give a very brief answer. 3.02. What is the ratio of the Oil Rent (as % of GDP) in Spain in 1985 to that in 1986?
Make the answer very short. 3.74. What is the ratio of the Oil Rent (as % of GDP) of United Kingdom in 1985 to that in 1986?
Make the answer very short. 2.85. What is the difference between the highest and the second highest Oil Rent (as % of GDP) in Israel?
Provide a short and direct response. 0.19. What is the difference between the highest and the second highest Oil Rent (as % of GDP) of Italy?
Provide a short and direct response. 0. What is the difference between the highest and the second highest Oil Rent (as % of GDP) of Spain?
Offer a terse response. 0.08. What is the difference between the highest and the second highest Oil Rent (as % of GDP) of United Kingdom?
Offer a terse response. 0.47. What is the difference between the highest and the lowest Oil Rent (as % of GDP) in Israel?
Give a very brief answer. 2.05. What is the difference between the highest and the lowest Oil Rent (as % of GDP) in Italy?
Provide a succinct answer. 0.07. What is the difference between the highest and the lowest Oil Rent (as % of GDP) of Spain?
Provide a succinct answer. 0.27. What is the difference between the highest and the lowest Oil Rent (as % of GDP) in United Kingdom?
Your answer should be very brief. 3.25. 